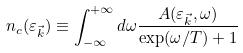Convert formula to latex. <formula><loc_0><loc_0><loc_500><loc_500>n _ { c } ( \varepsilon _ { \vec { k } } ) \equiv \int _ { - \infty } ^ { + \infty } d \omega \frac { A ( \varepsilon _ { \vec { k } } , \omega ) } { \exp ( \omega / T ) + 1 }</formula> 